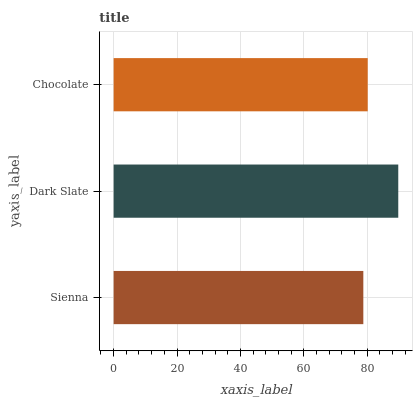Is Sienna the minimum?
Answer yes or no. Yes. Is Dark Slate the maximum?
Answer yes or no. Yes. Is Chocolate the minimum?
Answer yes or no. No. Is Chocolate the maximum?
Answer yes or no. No. Is Dark Slate greater than Chocolate?
Answer yes or no. Yes. Is Chocolate less than Dark Slate?
Answer yes or no. Yes. Is Chocolate greater than Dark Slate?
Answer yes or no. No. Is Dark Slate less than Chocolate?
Answer yes or no. No. Is Chocolate the high median?
Answer yes or no. Yes. Is Chocolate the low median?
Answer yes or no. Yes. Is Sienna the high median?
Answer yes or no. No. Is Dark Slate the low median?
Answer yes or no. No. 